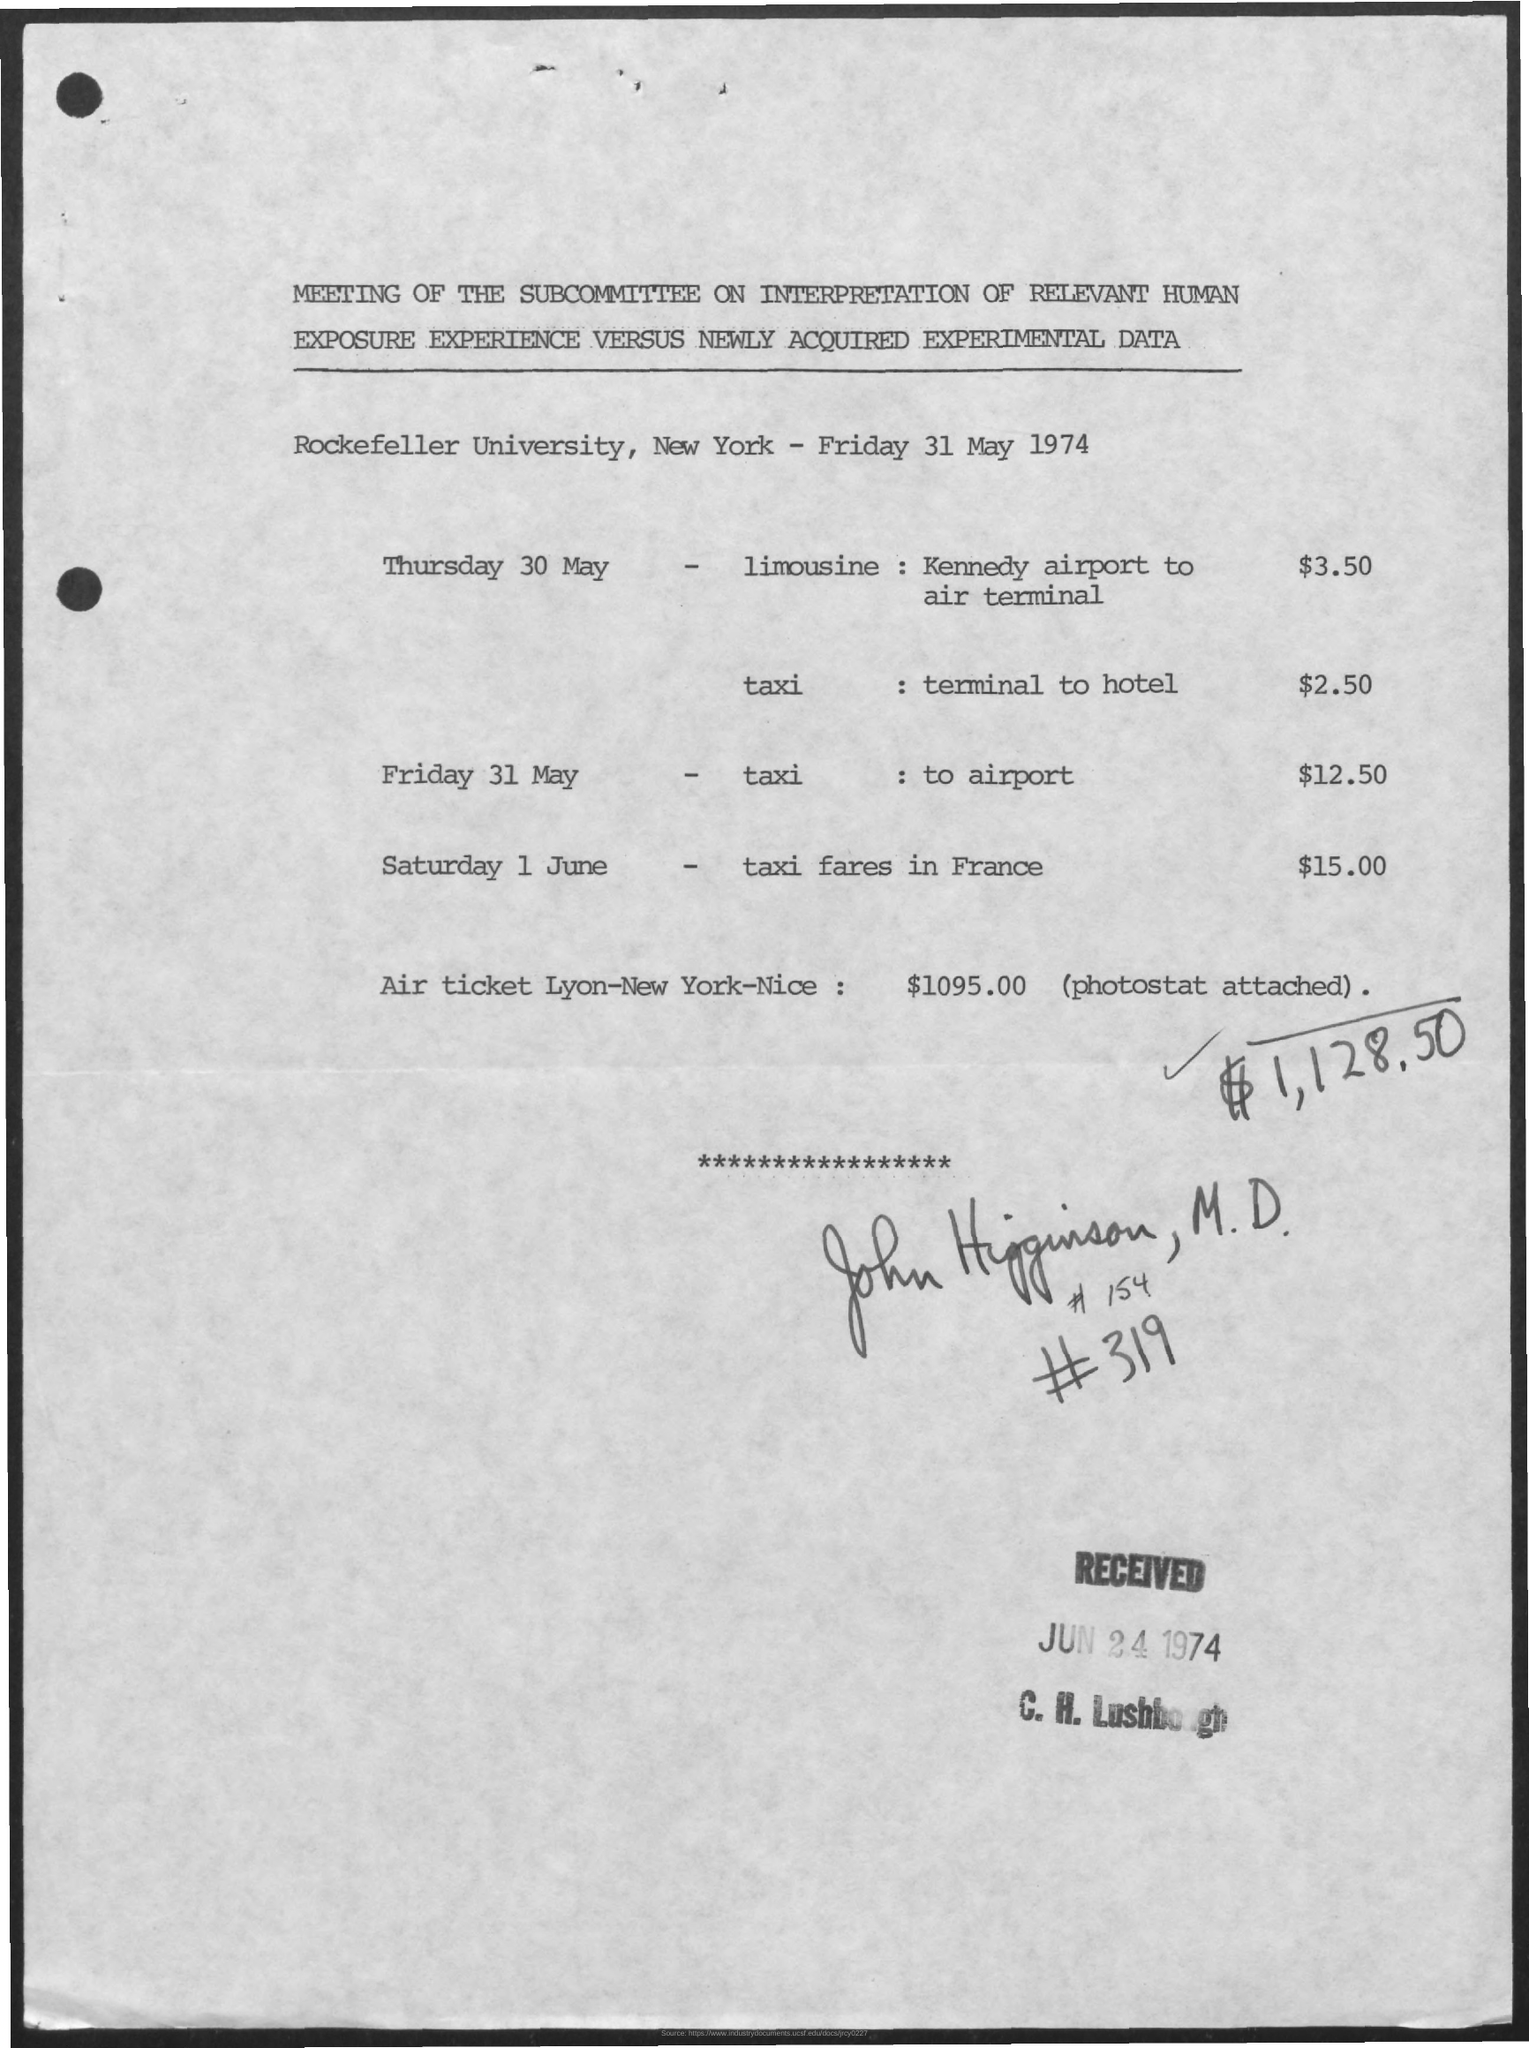What is the date Received?
Provide a short and direct response. Jun 24 1974. What is the taxi fares in France on Saturday 1 June?
Give a very brief answer. $15.00. What is the taxi fare to the airport on Friday 31 May?
Make the answer very short. $12.50. What is the taxi fare from terminal to the hotel on Thursday 30 May?
Your answer should be compact. $2.50. 